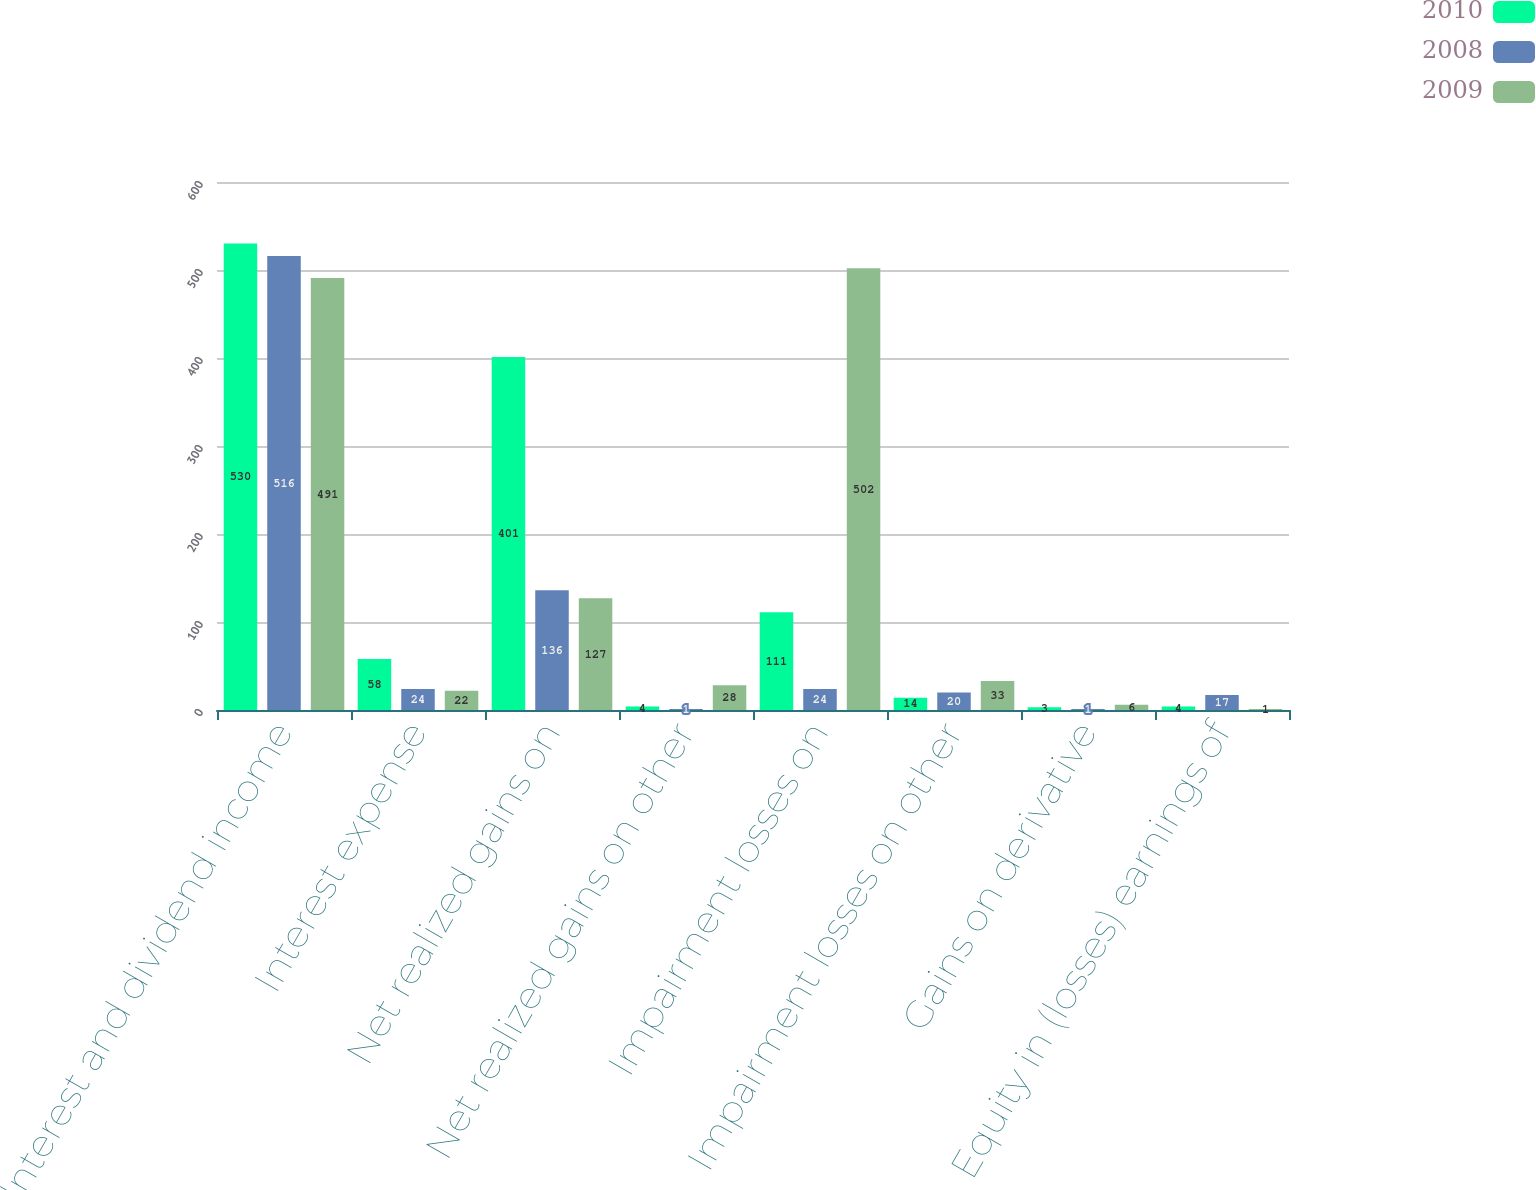Convert chart to OTSL. <chart><loc_0><loc_0><loc_500><loc_500><stacked_bar_chart><ecel><fcel>Interest and dividend income<fcel>Interest expense<fcel>Net realized gains on<fcel>Net realized gains on other<fcel>Impairment losses on<fcel>Impairment losses on other<fcel>Gains on derivative<fcel>Equity in (losses) earnings of<nl><fcel>2010<fcel>530<fcel>58<fcel>401<fcel>4<fcel>111<fcel>14<fcel>3<fcel>4<nl><fcel>2008<fcel>516<fcel>24<fcel>136<fcel>1<fcel>24<fcel>20<fcel>1<fcel>17<nl><fcel>2009<fcel>491<fcel>22<fcel>127<fcel>28<fcel>502<fcel>33<fcel>6<fcel>1<nl></chart> 